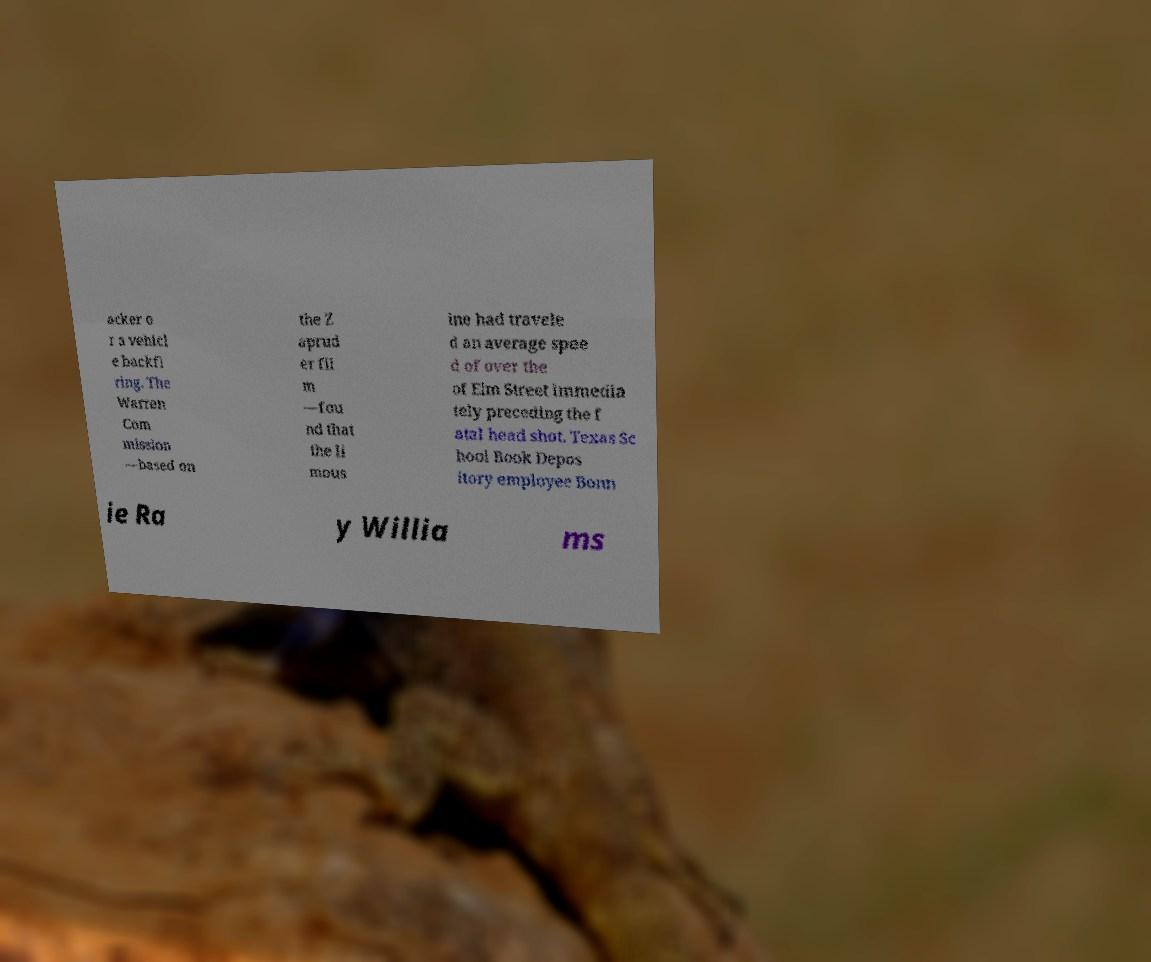Could you extract and type out the text from this image? acker o r a vehicl e backfi ring. The Warren Com mission —based on the Z aprud er fil m —fou nd that the li mous ine had travele d an average spee d of over the of Elm Street immedia tely preceding the f atal head shot. Texas Sc hool Book Depos itory employee Bonn ie Ra y Willia ms 